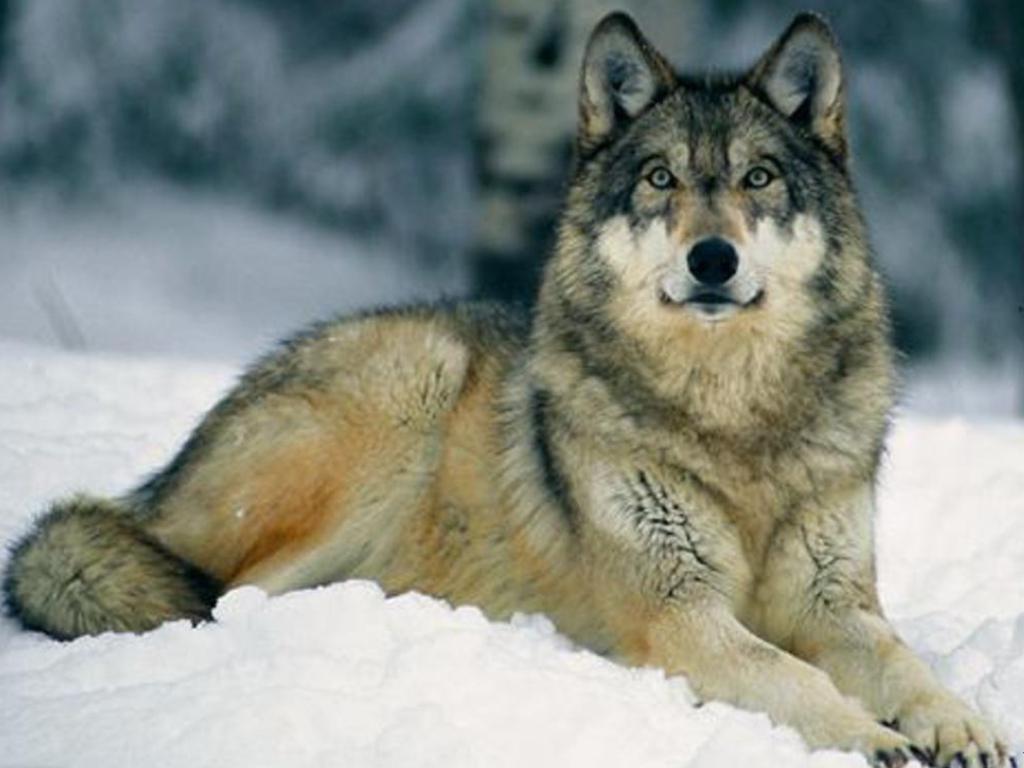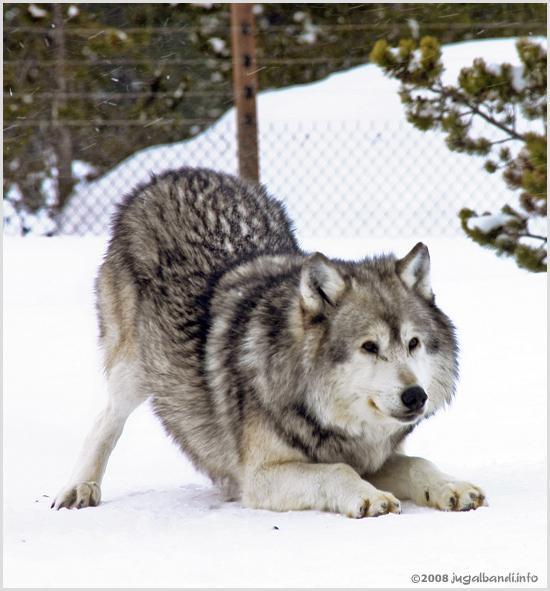The first image is the image on the left, the second image is the image on the right. Considering the images on both sides, is "The left image shows a camera-gazing wolf with a bit of snow on its fur, and the right image contains two wolves in the foreground." valid? Answer yes or no. No. The first image is the image on the left, the second image is the image on the right. Considering the images on both sides, is "You can see two or more wolves side by side in one of the pictures." valid? Answer yes or no. No. 